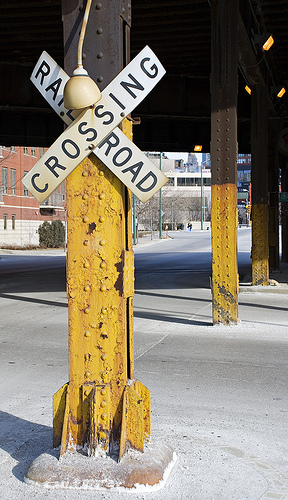Extract all visible text content from this image. CROSSING RAILROAD 